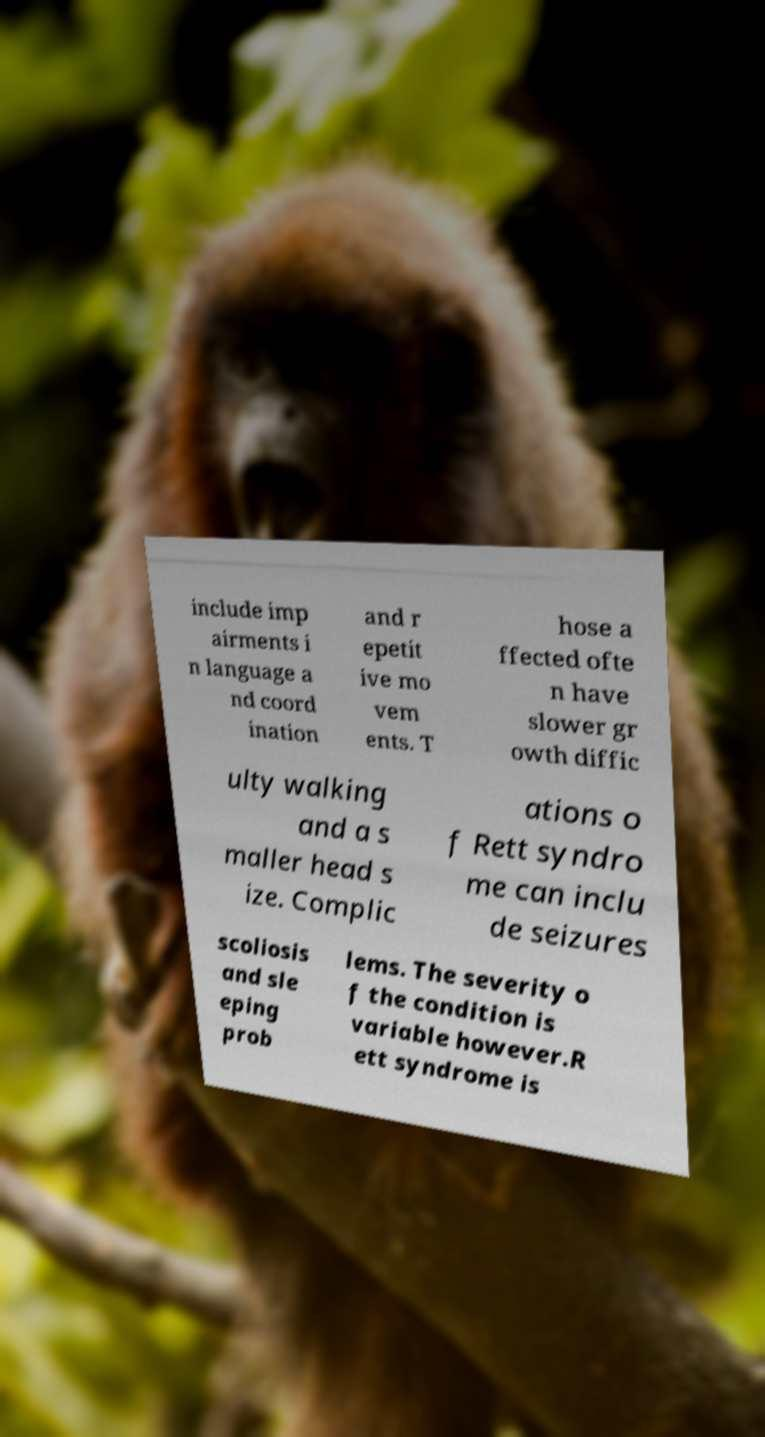Could you extract and type out the text from this image? include imp airments i n language a nd coord ination and r epetit ive mo vem ents. T hose a ffected ofte n have slower gr owth diffic ulty walking and a s maller head s ize. Complic ations o f Rett syndro me can inclu de seizures scoliosis and sle eping prob lems. The severity o f the condition is variable however.R ett syndrome is 